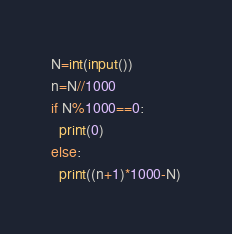<code> <loc_0><loc_0><loc_500><loc_500><_Python_>N=int(input())
n=N//1000
if N%1000==0:
  print(0)
else:
  print((n+1)*1000-N)</code> 